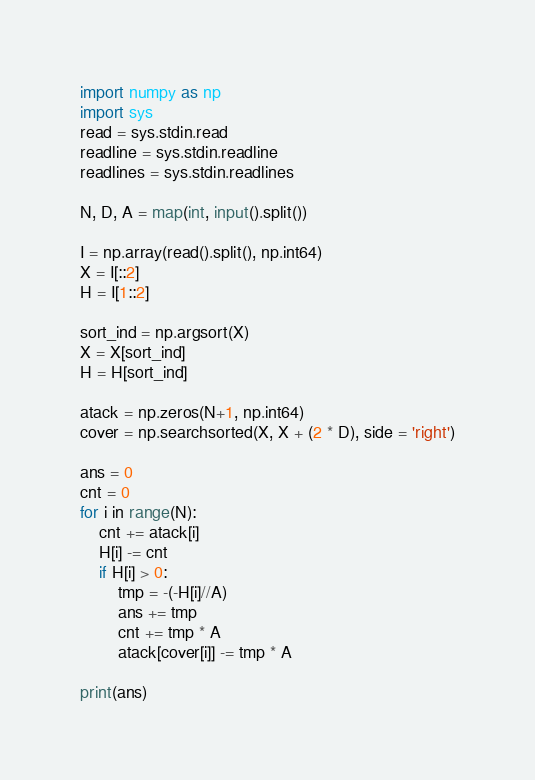Convert code to text. <code><loc_0><loc_0><loc_500><loc_500><_Python_>import numpy as np
import sys
read = sys.stdin.read
readline = sys.stdin.readline
readlines = sys.stdin.readlines

N, D, A = map(int, input().split())

I = np.array(read().split(), np.int64)
X = I[::2]
H = I[1::2]

sort_ind = np.argsort(X)
X = X[sort_ind]
H = H[sort_ind]

atack = np.zeros(N+1, np.int64)
cover = np.searchsorted(X, X + (2 * D), side = 'right')

ans = 0
cnt = 0
for i in range(N):
	cnt += atack[i]
	H[i] -= cnt
	if H[i] > 0:
		tmp = -(-H[i]//A)
		ans += tmp
		cnt += tmp * A
		atack[cover[i]] -= tmp * A

print(ans)</code> 